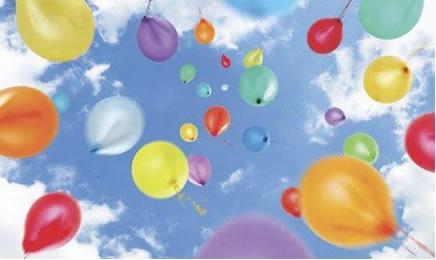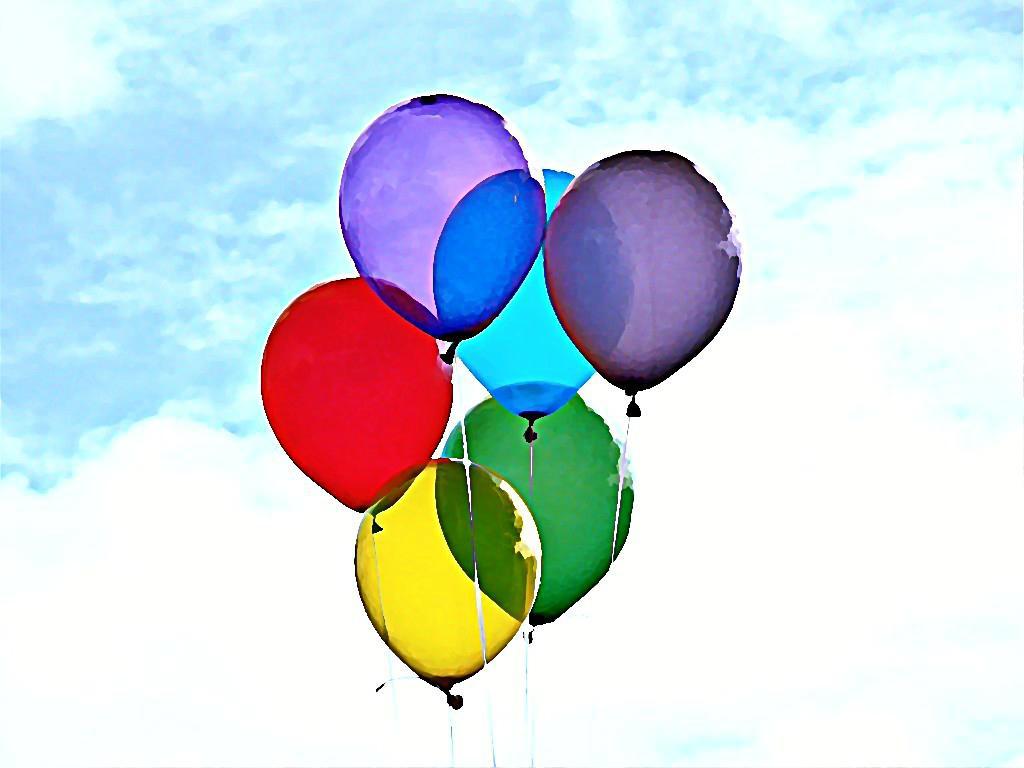The first image is the image on the left, the second image is the image on the right. Considering the images on both sides, is "An image shows an upward view of at least one balloon on a string ascending into a cloud-studded blue sky." valid? Answer yes or no. Yes. The first image is the image on the left, the second image is the image on the right. For the images shown, is this caption "there are a bunch of balloons gathered together by strings and all the purple balloons are on the bottom" true? Answer yes or no. No. 